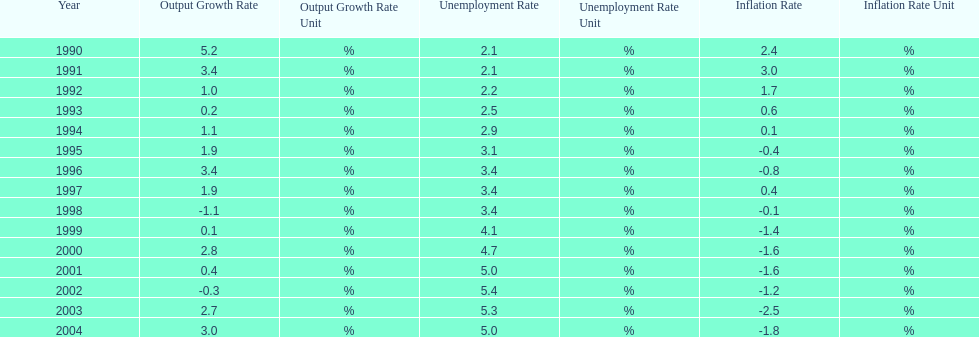When in the 1990's did the inflation rate first become negative? 1995. 